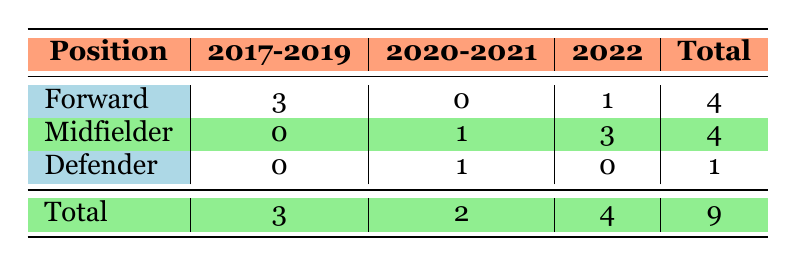What is the total number of forwards transferred from South American clubs to European leagues from 2017 to 2022? By looking at the table, we see there are 3 forwards transferred in the years 2017-2019 and 1 more in 2022. So, the total number of forwards is 3 + 1 = 4.
Answer: 4 In which year were the most midfielders transferred? The table shows that in 2022, there were 3 midfielders transferred. In 2020-2021, there was 1 midfielder transferred. Summing these up, 2022 has the highest count of midfielders.
Answer: 2022 True or false: There were no defenders transferred in 2022. The table indicates that there were 0 defenders transferred in 2022. Therefore, this statement is true.
Answer: True What percentage of total transfers were forwards? The total number of transfers is 9. There are 4 forwards. To find the percentage, we calculate (4/9) * 100, which gives approximately 44.44%.
Answer: 44.44% How many total players were transferred in the year 2020-2021? The table shows that there were 2 players transferred in the year 2020-2021 (1 midfielder and 1 defender). Therefore, the total is simply 2.
Answer: 2 What is the difference in the number of transferred forwards and midfielders in 2021? The number of forwards is 0 and the number of midfielders is 1 in 2020-2021. Therefore, the difference is 0 - 1 = -1.
Answer: -1 How many total defenders were transferred across all years? The table shows there was 1 defender transferred in the year 2020-2021 and 0 defenders in other years, making the total 1.
Answer: 1 Which position had the least amount of players transferred over the entire time period? The table indicates that there is 1 defender and 4 midfielders and 4 forwards in total. Thus, defenders had the least number of transfers.
Answer: Defender 